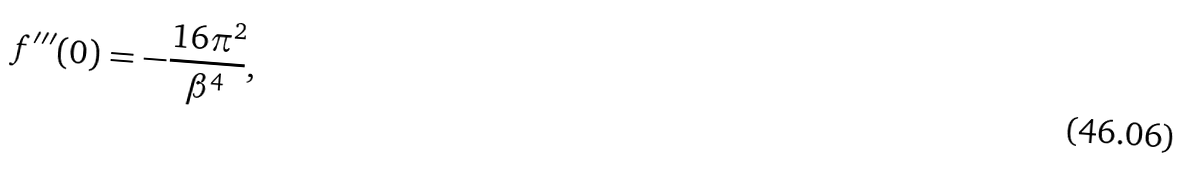Convert formula to latex. <formula><loc_0><loc_0><loc_500><loc_500>f ^ { \prime \prime \prime } ( 0 ) = - \frac { 1 6 \pi ^ { 2 } } { \beta ^ { 4 } } ,</formula> 